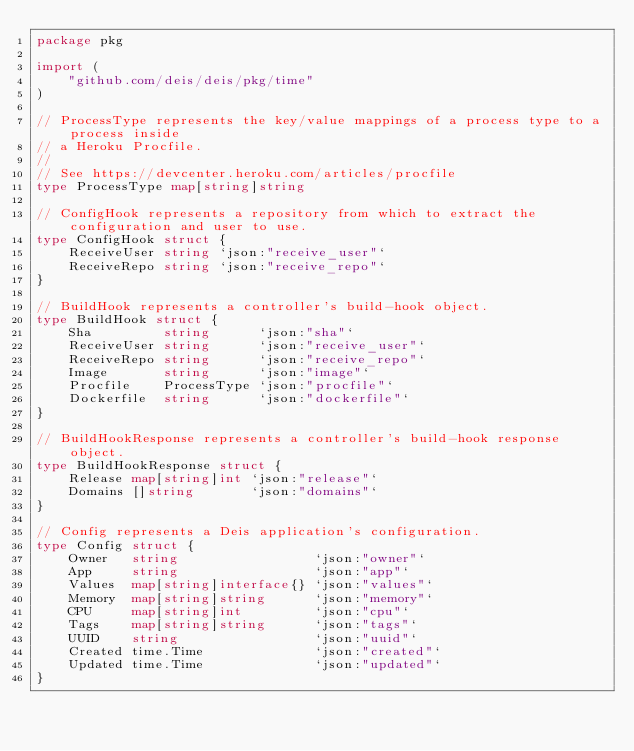Convert code to text. <code><loc_0><loc_0><loc_500><loc_500><_Go_>package pkg

import (
	"github.com/deis/deis/pkg/time"
)

// ProcessType represents the key/value mappings of a process type to a process inside
// a Heroku Procfile.
//
// See https://devcenter.heroku.com/articles/procfile
type ProcessType map[string]string

// ConfigHook represents a repository from which to extract the configuration and user to use.
type ConfigHook struct {
	ReceiveUser string `json:"receive_user"`
	ReceiveRepo string `json:"receive_repo"`
}

// BuildHook represents a controller's build-hook object.
type BuildHook struct {
	Sha         string      `json:"sha"`
	ReceiveUser string      `json:"receive_user"`
	ReceiveRepo string      `json:"receive_repo"`
	Image       string      `json:"image"`
	Procfile    ProcessType `json:"procfile"`
	Dockerfile  string      `json:"dockerfile"`
}

// BuildHookResponse represents a controller's build-hook response object.
type BuildHookResponse struct {
	Release map[string]int `json:"release"`
	Domains []string       `json:"domains"`
}

// Config represents a Deis application's configuration.
type Config struct {
	Owner   string                 `json:"owner"`
	App     string                 `json:"app"`
	Values  map[string]interface{} `json:"values"`
	Memory  map[string]string      `json:"memory"`
	CPU     map[string]int         `json:"cpu"`
	Tags    map[string]string      `json:"tags"`
	UUID    string                 `json:"uuid"`
	Created time.Time              `json:"created"`
	Updated time.Time              `json:"updated"`
}
</code> 